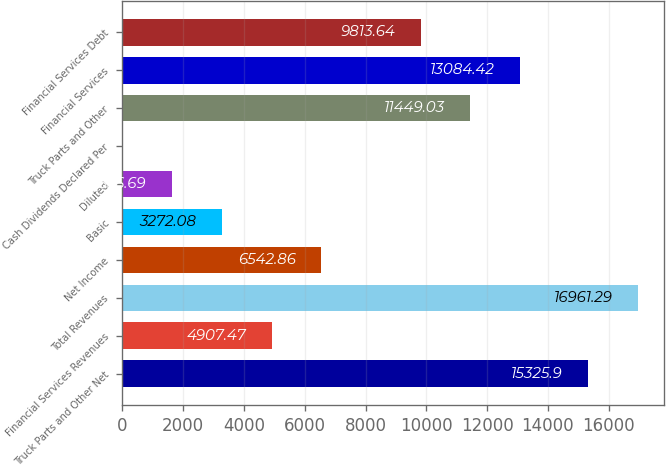Convert chart. <chart><loc_0><loc_0><loc_500><loc_500><bar_chart><fcel>Truck Parts and Other Net<fcel>Financial Services Revenues<fcel>Total Revenues<fcel>Net Income<fcel>Basic<fcel>Diluted<fcel>Cash Dividends Declared Per<fcel>Truck Parts and Other<fcel>Financial Services<fcel>Financial Services Debt<nl><fcel>15325.9<fcel>4907.47<fcel>16961.3<fcel>6542.86<fcel>3272.08<fcel>1636.69<fcel>1.3<fcel>11449<fcel>13084.4<fcel>9813.64<nl></chart> 